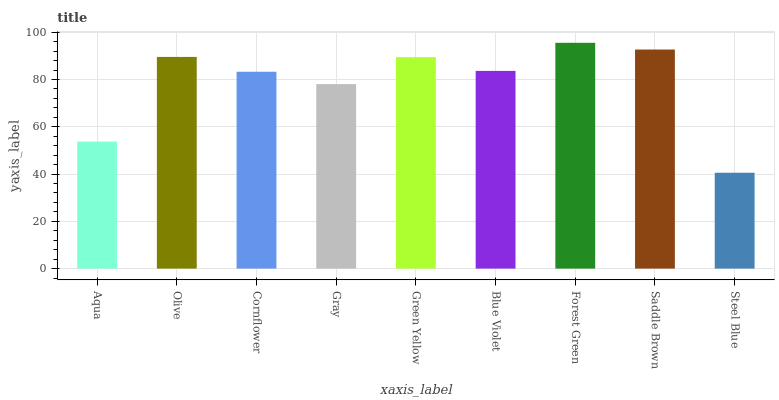Is Steel Blue the minimum?
Answer yes or no. Yes. Is Forest Green the maximum?
Answer yes or no. Yes. Is Olive the minimum?
Answer yes or no. No. Is Olive the maximum?
Answer yes or no. No. Is Olive greater than Aqua?
Answer yes or no. Yes. Is Aqua less than Olive?
Answer yes or no. Yes. Is Aqua greater than Olive?
Answer yes or no. No. Is Olive less than Aqua?
Answer yes or no. No. Is Blue Violet the high median?
Answer yes or no. Yes. Is Blue Violet the low median?
Answer yes or no. Yes. Is Olive the high median?
Answer yes or no. No. Is Gray the low median?
Answer yes or no. No. 